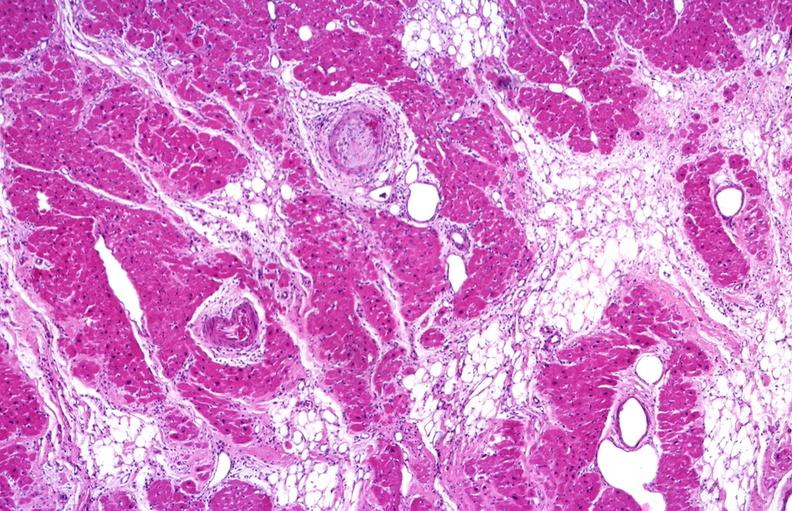does coronary artery show heart, polyarteritis nodosa?
Answer the question using a single word or phrase. No 